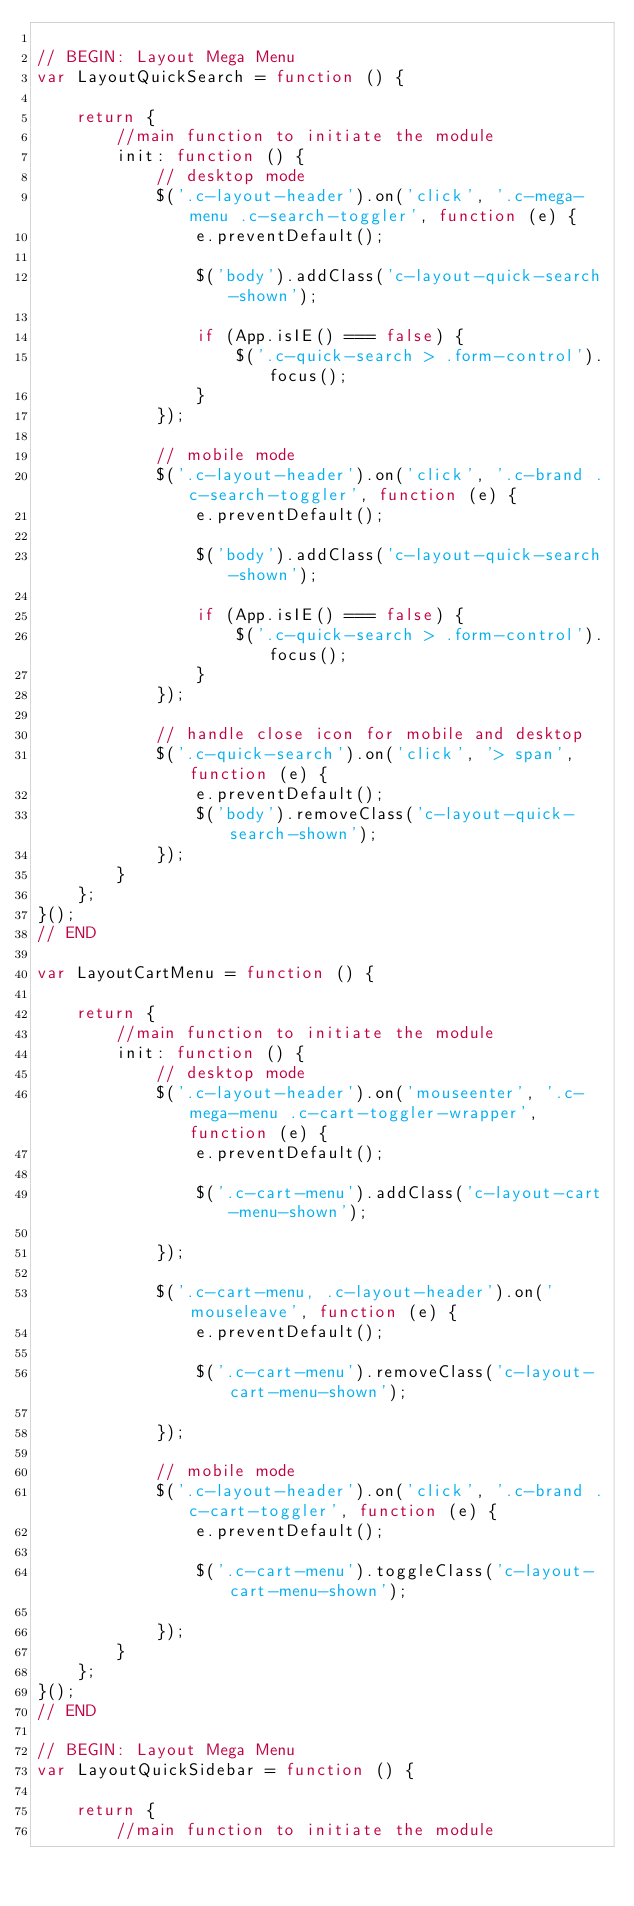Convert code to text. <code><loc_0><loc_0><loc_500><loc_500><_JavaScript_>
// BEGIN: Layout Mega Menu
var LayoutQuickSearch = function () {

	return {
		//main function to initiate the module
		init: function () {
			// desktop mode
			$('.c-layout-header').on('click', '.c-mega-menu .c-search-toggler', function (e) {
				e.preventDefault();

				$('body').addClass('c-layout-quick-search-shown');

				if (App.isIE() === false) {
					$('.c-quick-search > .form-control').focus();
				}
			});

			// mobile mode
			$('.c-layout-header').on('click', '.c-brand .c-search-toggler', function (e) {
				e.preventDefault();

				$('body').addClass('c-layout-quick-search-shown');

				if (App.isIE() === false) {
					$('.c-quick-search > .form-control').focus();
				}
			});

			// handle close icon for mobile and desktop
			$('.c-quick-search').on('click', '> span', function (e) {
				e.preventDefault();
				$('body').removeClass('c-layout-quick-search-shown');
			});
		}
	};
}();
// END

var LayoutCartMenu = function () {

	return {
		//main function to initiate the module
		init: function () {
			// desktop mode
			$('.c-layout-header').on('mouseenter', '.c-mega-menu .c-cart-toggler-wrapper', function (e) {
				e.preventDefault();

				$('.c-cart-menu').addClass('c-layout-cart-menu-shown');

			});

			$('.c-cart-menu, .c-layout-header').on('mouseleave', function (e) {
				e.preventDefault();

				$('.c-cart-menu').removeClass('c-layout-cart-menu-shown');

			});

			// mobile mode
			$('.c-layout-header').on('click', '.c-brand .c-cart-toggler', function (e) {
				e.preventDefault();

				$('.c-cart-menu').toggleClass('c-layout-cart-menu-shown');

			});
		}
	};
}();
// END

// BEGIN: Layout Mega Menu
var LayoutQuickSidebar = function () {

	return {
		//main function to initiate the module</code> 